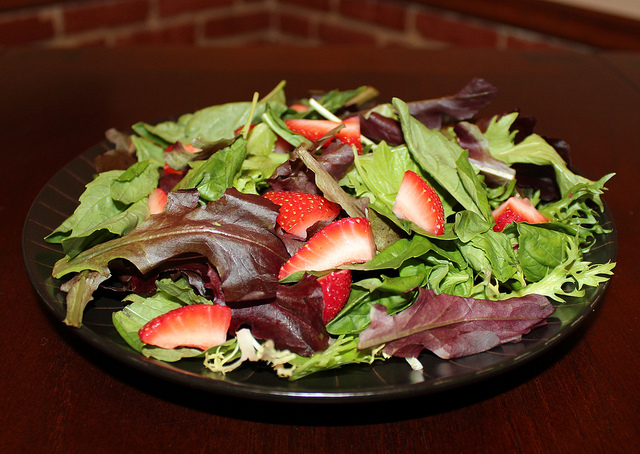What types of greens can be seen in the salad? The salad includes a mixture of leafy greens like arugula and possibly types of lettuce such as romaine and red leaf lettuce, providing a vibrant base for the included strawberries. 